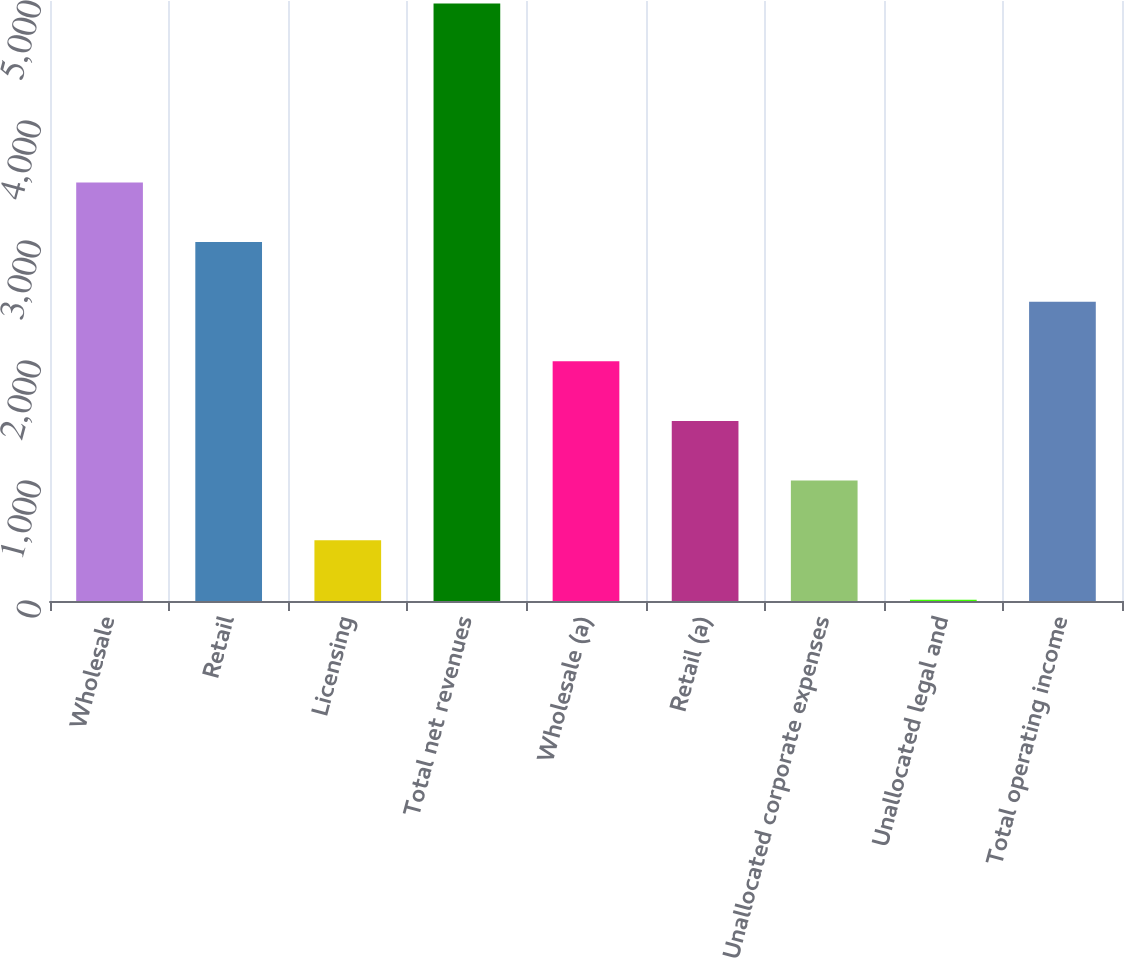Convert chart to OTSL. <chart><loc_0><loc_0><loc_500><loc_500><bar_chart><fcel>Wholesale<fcel>Retail<fcel>Licensing<fcel>Total net revenues<fcel>Wholesale (a)<fcel>Retail (a)<fcel>Unallocated corporate expenses<fcel>Unallocated legal and<fcel>Total operating income<nl><fcel>3488.23<fcel>2991.34<fcel>506.89<fcel>4978.9<fcel>1997.56<fcel>1500.67<fcel>1003.78<fcel>10<fcel>2494.45<nl></chart> 